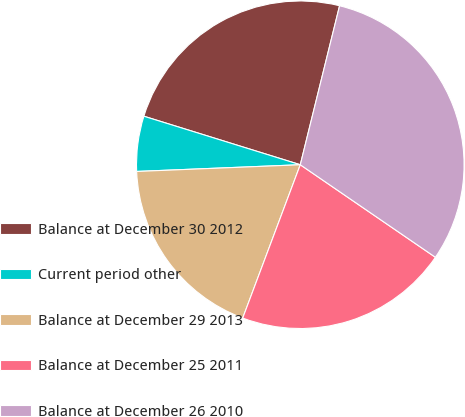Convert chart to OTSL. <chart><loc_0><loc_0><loc_500><loc_500><pie_chart><fcel>Balance at December 30 2012<fcel>Current period other<fcel>Balance at December 29 2013<fcel>Balance at December 25 2011<fcel>Balance at December 26 2010<nl><fcel>24.07%<fcel>5.44%<fcel>18.63%<fcel>21.16%<fcel>30.7%<nl></chart> 